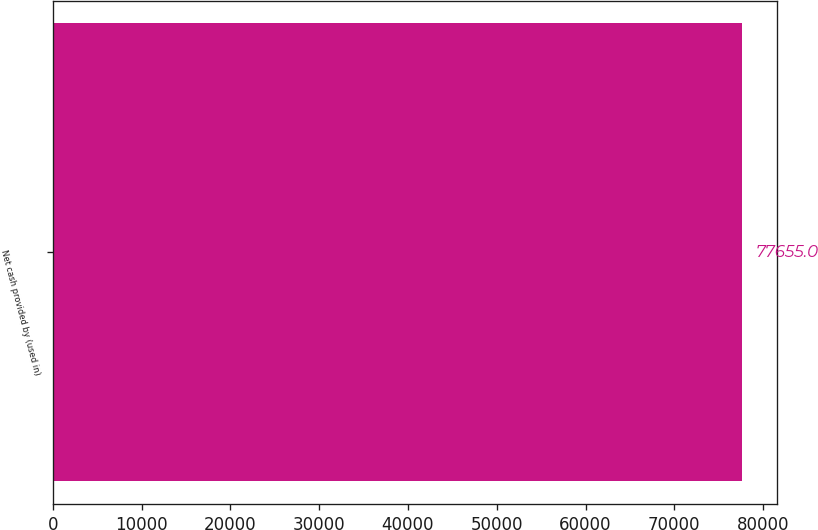Convert chart to OTSL. <chart><loc_0><loc_0><loc_500><loc_500><bar_chart><fcel>Net cash provided by (used in)<nl><fcel>77655<nl></chart> 